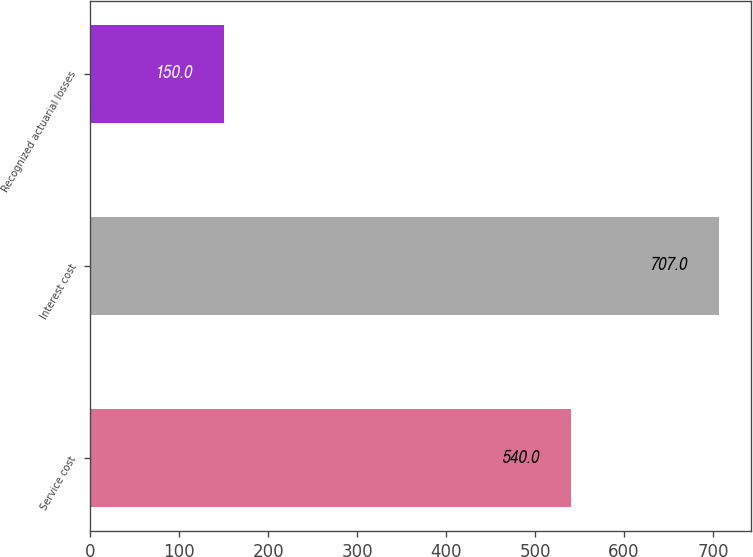Convert chart. <chart><loc_0><loc_0><loc_500><loc_500><bar_chart><fcel>Service cost<fcel>Interest cost<fcel>Recognized actuarial losses<nl><fcel>540<fcel>707<fcel>150<nl></chart> 